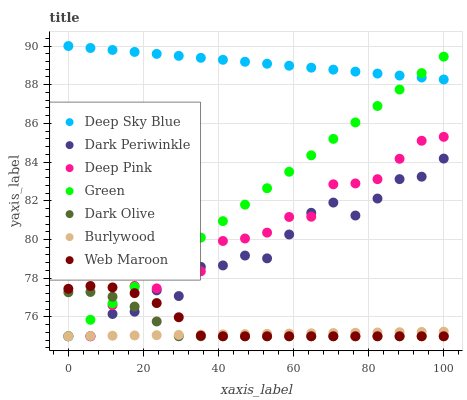Does Burlywood have the minimum area under the curve?
Answer yes or no. Yes. Does Deep Sky Blue have the maximum area under the curve?
Answer yes or no. Yes. Does Dark Olive have the minimum area under the curve?
Answer yes or no. No. Does Dark Olive have the maximum area under the curve?
Answer yes or no. No. Is Burlywood the smoothest?
Answer yes or no. Yes. Is Dark Periwinkle the roughest?
Answer yes or no. Yes. Is Dark Olive the smoothest?
Answer yes or no. No. Is Dark Olive the roughest?
Answer yes or no. No. Does Deep Pink have the lowest value?
Answer yes or no. Yes. Does Deep Sky Blue have the lowest value?
Answer yes or no. No. Does Deep Sky Blue have the highest value?
Answer yes or no. Yes. Does Dark Olive have the highest value?
Answer yes or no. No. Is Dark Olive less than Deep Sky Blue?
Answer yes or no. Yes. Is Deep Sky Blue greater than Dark Olive?
Answer yes or no. Yes. Does Green intersect Burlywood?
Answer yes or no. Yes. Is Green less than Burlywood?
Answer yes or no. No. Is Green greater than Burlywood?
Answer yes or no. No. Does Dark Olive intersect Deep Sky Blue?
Answer yes or no. No. 